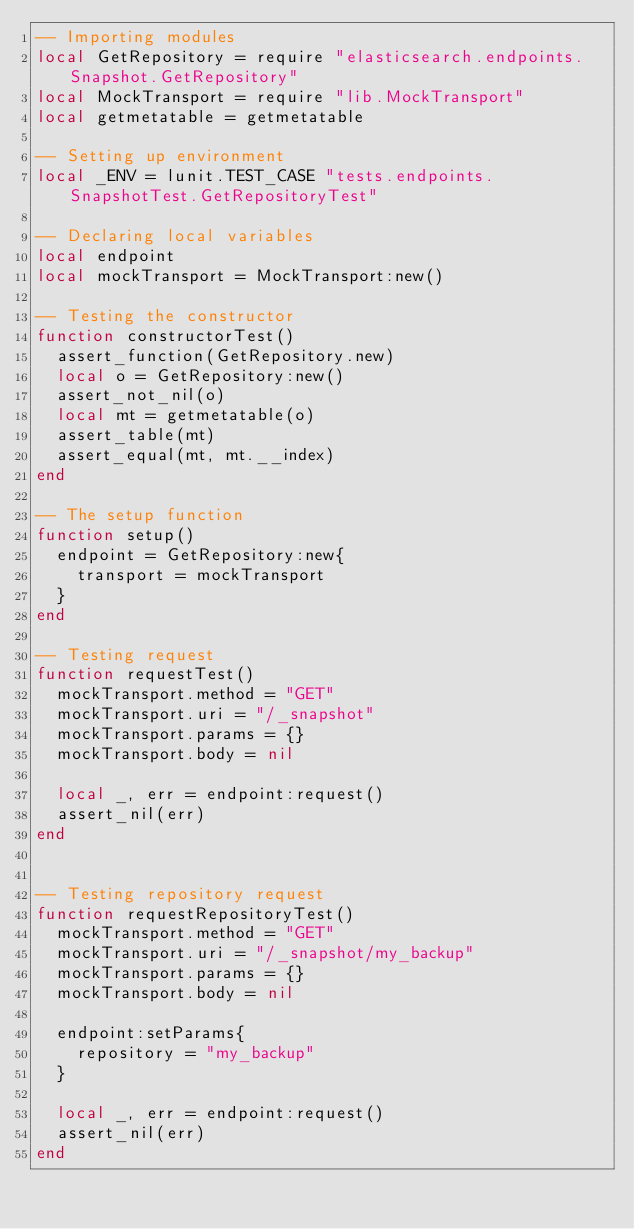<code> <loc_0><loc_0><loc_500><loc_500><_Lua_>-- Importing modules
local GetRepository = require "elasticsearch.endpoints.Snapshot.GetRepository"
local MockTransport = require "lib.MockTransport"
local getmetatable = getmetatable

-- Setting up environment
local _ENV = lunit.TEST_CASE "tests.endpoints.SnapshotTest.GetRepositoryTest"

-- Declaring local variables
local endpoint
local mockTransport = MockTransport:new()

-- Testing the constructor
function constructorTest()
  assert_function(GetRepository.new)
  local o = GetRepository:new()
  assert_not_nil(o)
  local mt = getmetatable(o)
  assert_table(mt)
  assert_equal(mt, mt.__index)
end

-- The setup function
function setup()
  endpoint = GetRepository:new{
    transport = mockTransport
  }
end

-- Testing request
function requestTest()
  mockTransport.method = "GET"
  mockTransport.uri = "/_snapshot"
  mockTransport.params = {}
  mockTransport.body = nil

  local _, err = endpoint:request()
  assert_nil(err)
end


-- Testing repository request
function requestRepositoryTest()
  mockTransport.method = "GET"
  mockTransport.uri = "/_snapshot/my_backup"
  mockTransport.params = {}
  mockTransport.body = nil

  endpoint:setParams{
    repository = "my_backup"
  }

  local _, err = endpoint:request()
  assert_nil(err)
end
</code> 